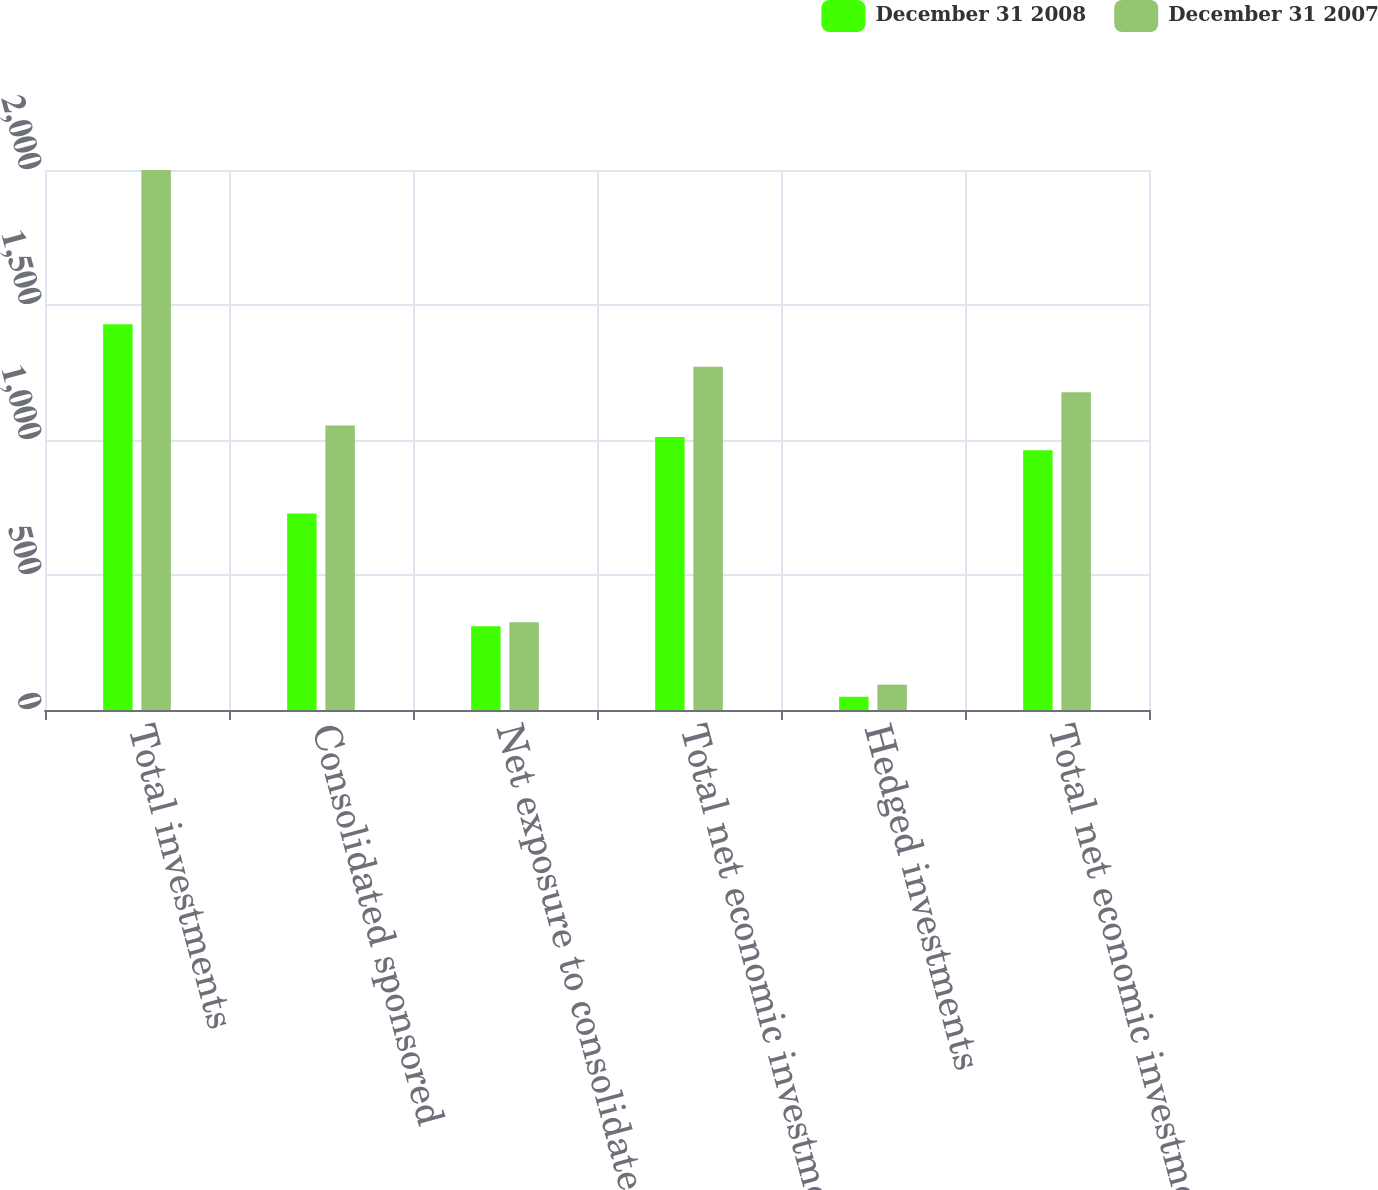Convert chart. <chart><loc_0><loc_0><loc_500><loc_500><stacked_bar_chart><ecel><fcel>Total investments<fcel>Consolidated sponsored<fcel>Net exposure to consolidated<fcel>Total net economic investments<fcel>Hedged investments<fcel>Total net economic investment<nl><fcel>December 31 2008<fcel>1429<fcel>728<fcel>310<fcel>1011<fcel>49<fcel>962<nl><fcel>December 31 2007<fcel>2000<fcel>1054<fcel>325<fcel>1271<fcel>94<fcel>1177<nl></chart> 